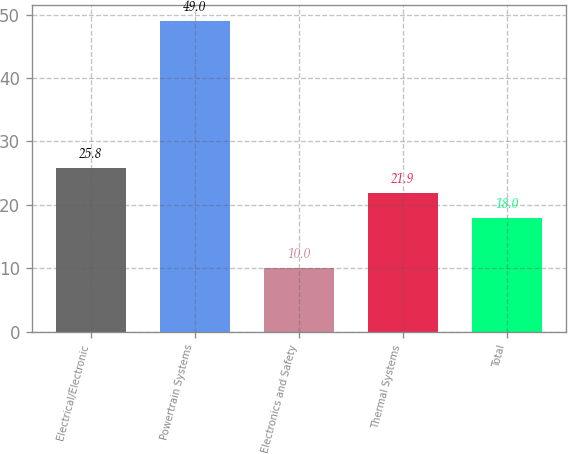<chart> <loc_0><loc_0><loc_500><loc_500><bar_chart><fcel>Electrical/Electronic<fcel>Powertrain Systems<fcel>Electronics and Safety<fcel>Thermal Systems<fcel>Total<nl><fcel>25.8<fcel>49<fcel>10<fcel>21.9<fcel>18<nl></chart> 